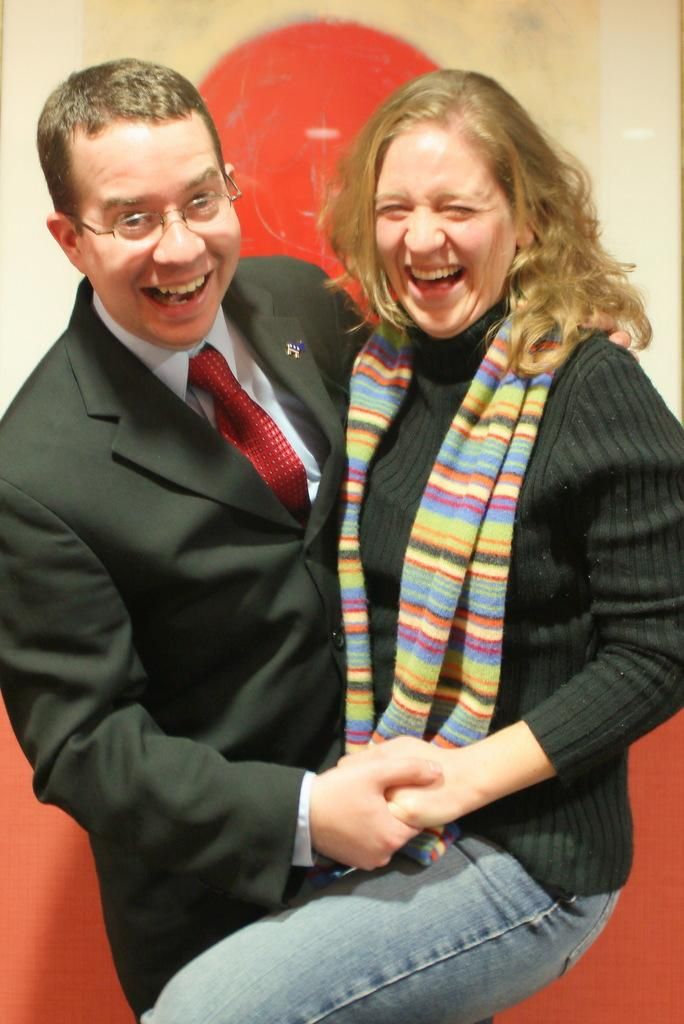Who is present in the image? There is a woman and a man in the image. What are the facial expressions of the woman and man? Both the woman and man are smiling in the image. How are the woman and man interacting with each other? The woman and man are holding hands in the image. What can be seen in the background of the image? There is a wall in the background of the image, and there is a red color element present. What type of donkey can be seen sorting values in the image? There is no donkey or sorting of values present in the image. 